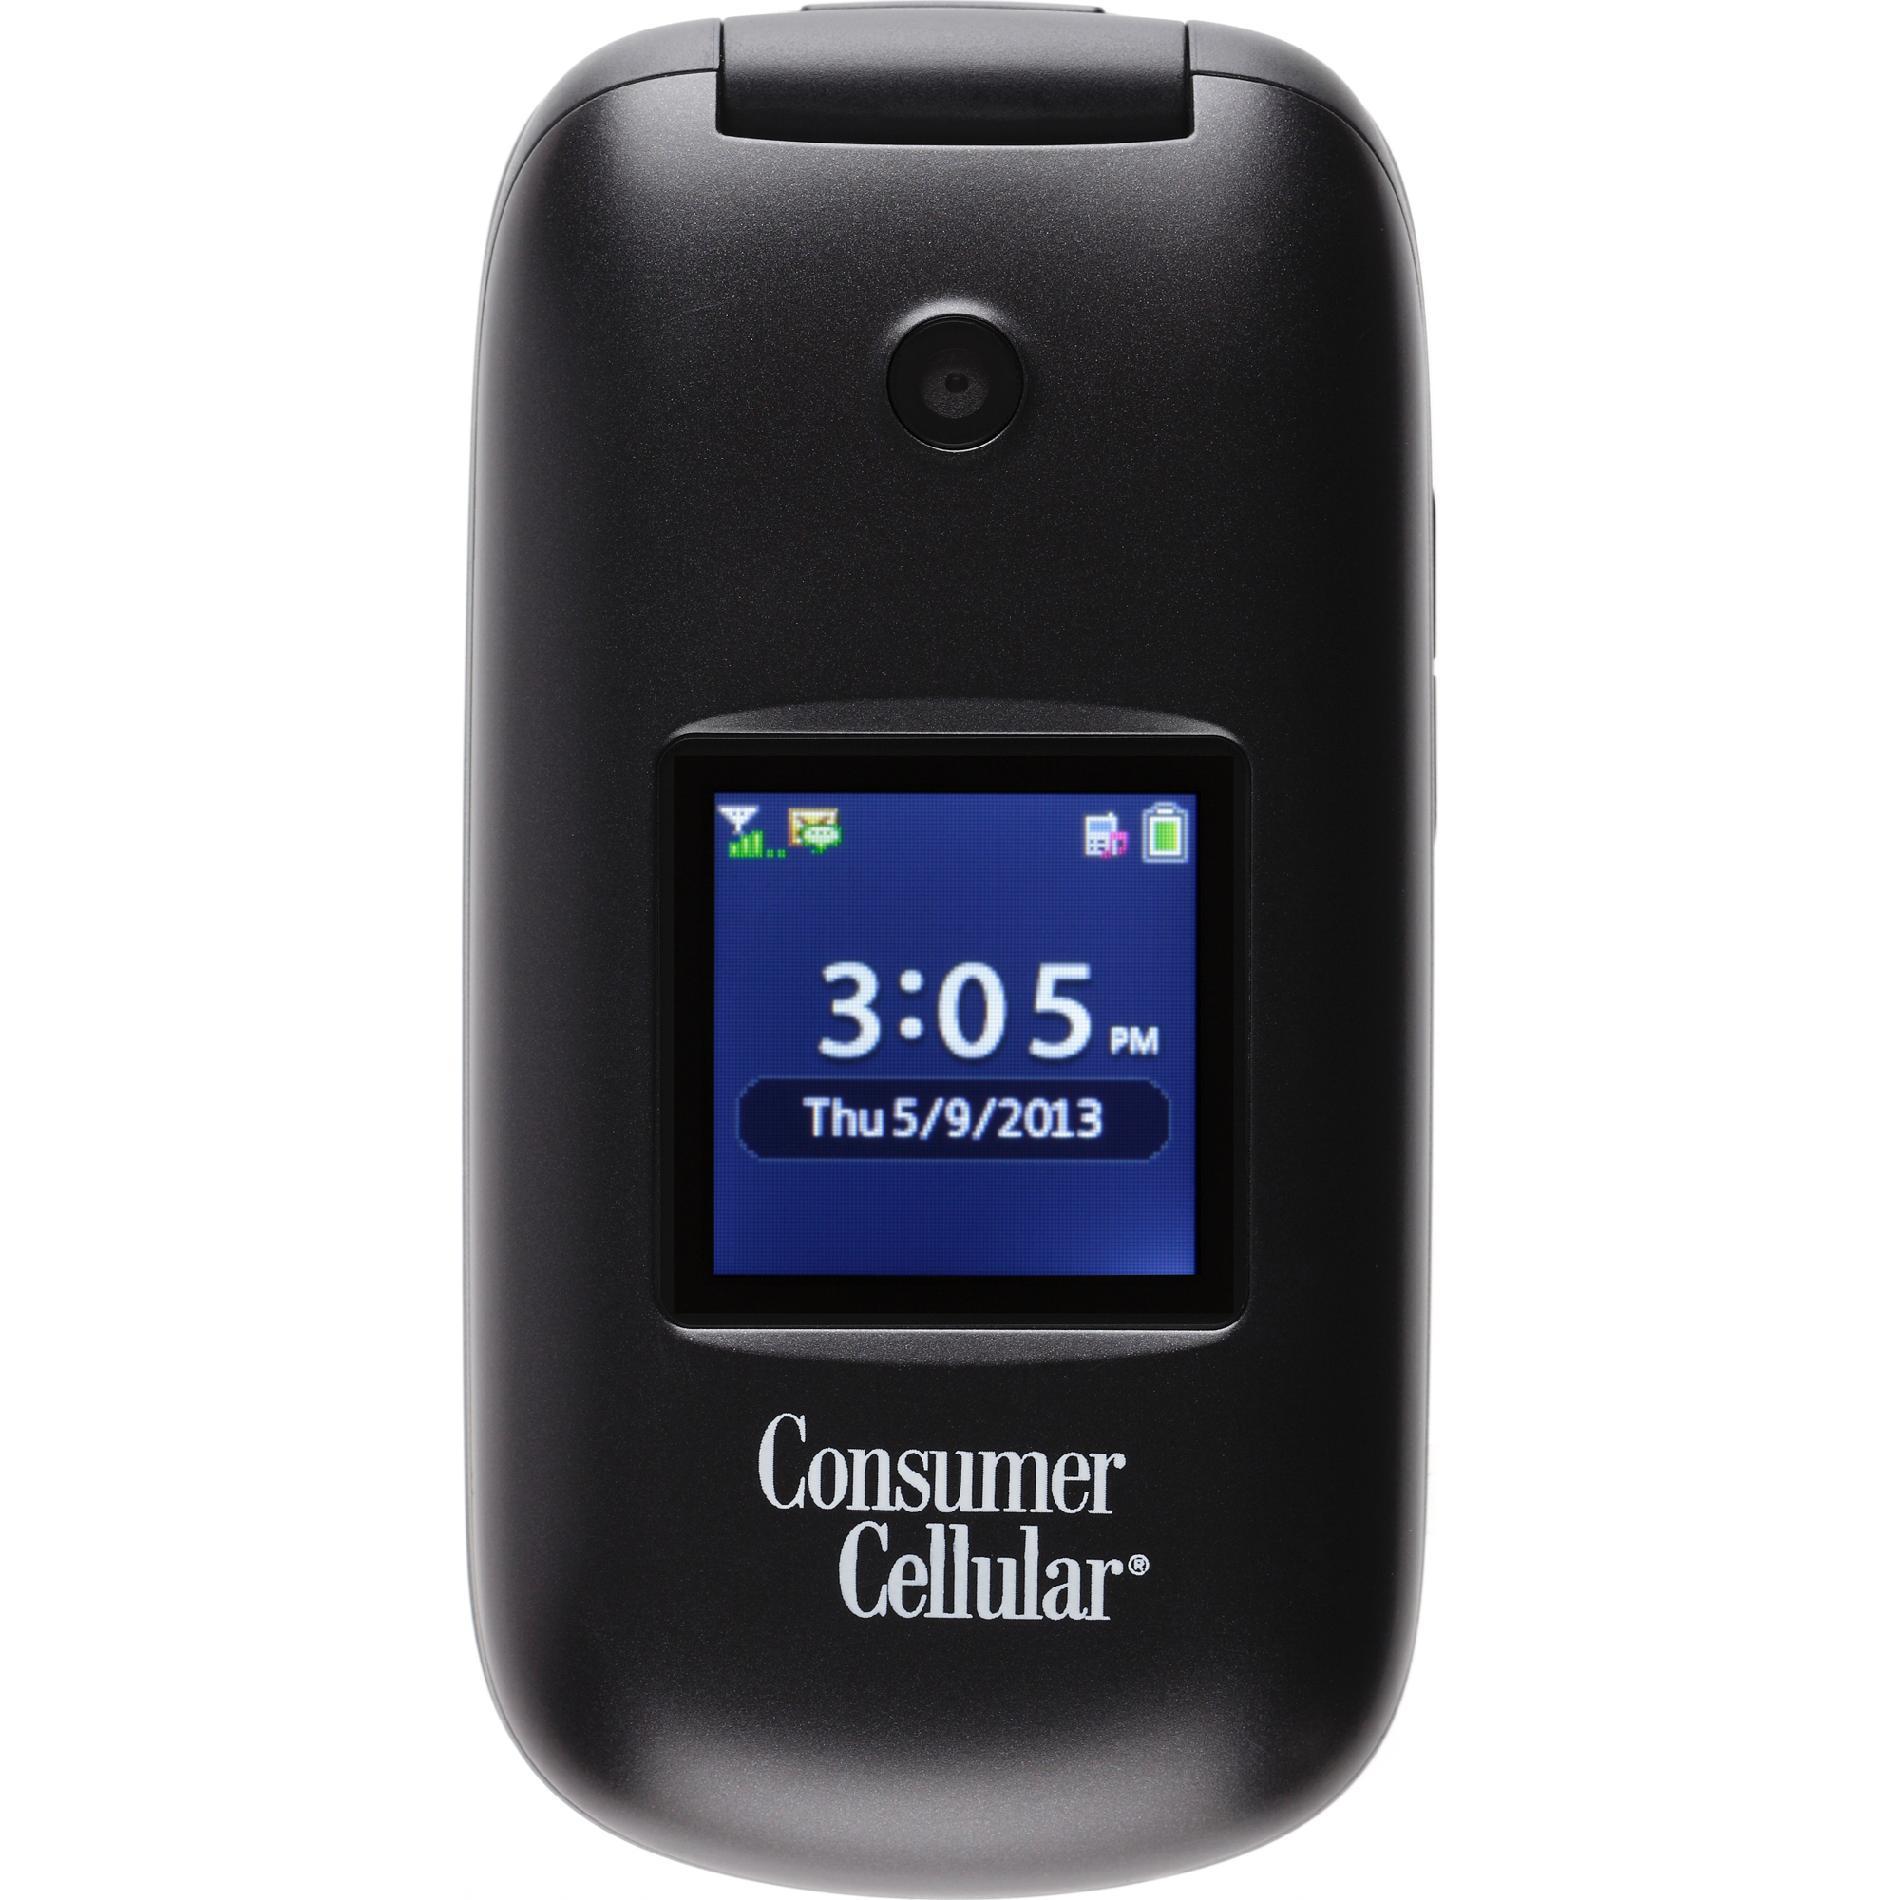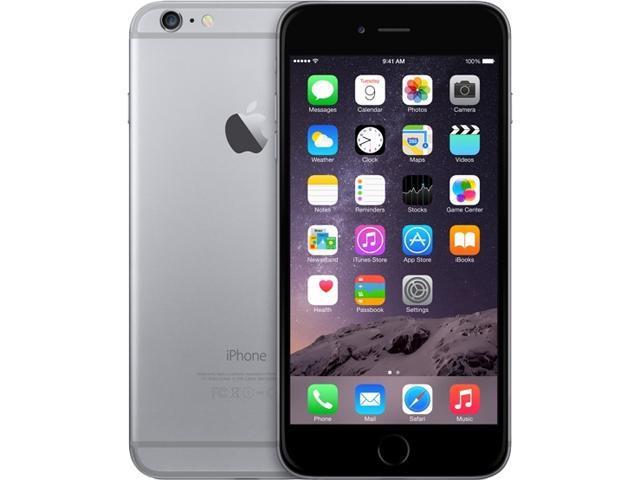The first image is the image on the left, the second image is the image on the right. Considering the images on both sides, is "Neither phone is an iPhone." valid? Answer yes or no. No. The first image is the image on the left, the second image is the image on the right. Evaluate the accuracy of this statement regarding the images: "Each image shows a rectangular device with flat ends and sides, rounded corners, and 'lit' screen displayed head-on, and at least one of the devices is black.". Is it true? Answer yes or no. No. 